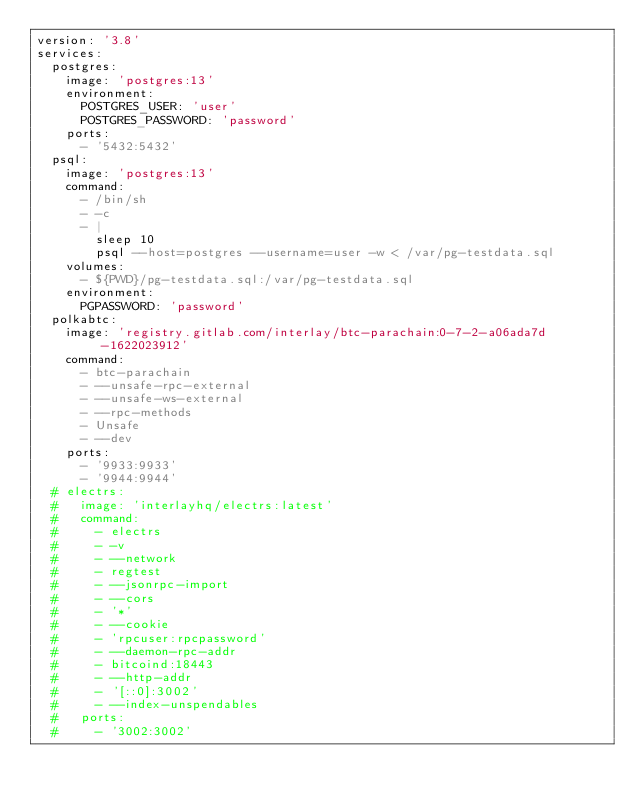Convert code to text. <code><loc_0><loc_0><loc_500><loc_500><_YAML_>version: '3.8'
services:
  postgres:
    image: 'postgres:13'
    environment:
      POSTGRES_USER: 'user'
      POSTGRES_PASSWORD: 'password'
    ports:
      - '5432:5432'
  psql:
    image: 'postgres:13'
    command:
      - /bin/sh
      - -c
      - |
        sleep 10
        psql --host=postgres --username=user -w < /var/pg-testdata.sql
    volumes:
      - ${PWD}/pg-testdata.sql:/var/pg-testdata.sql
    environment:
      PGPASSWORD: 'password'
  polkabtc:
    image: 'registry.gitlab.com/interlay/btc-parachain:0-7-2-a06ada7d-1622023912'
    command:
      - btc-parachain
      - --unsafe-rpc-external
      - --unsafe-ws-external
      - --rpc-methods
      - Unsafe
      - --dev
    ports:
      - '9933:9933'
      - '9944:9944'
  # electrs:
  #   image: 'interlayhq/electrs:latest'
  #   command:
  #     - electrs
  #     - -v
  #     - --network
  #     - regtest
  #     - --jsonrpc-import
  #     - --cors
  #     - '*'
  #     - --cookie
  #     - 'rpcuser:rpcpassword'
  #     - --daemon-rpc-addr
  #     - bitcoind:18443
  #     - --http-addr
  #     - '[::0]:3002'
  #     - --index-unspendables
  #   ports:
  #     - '3002:3002'
</code> 